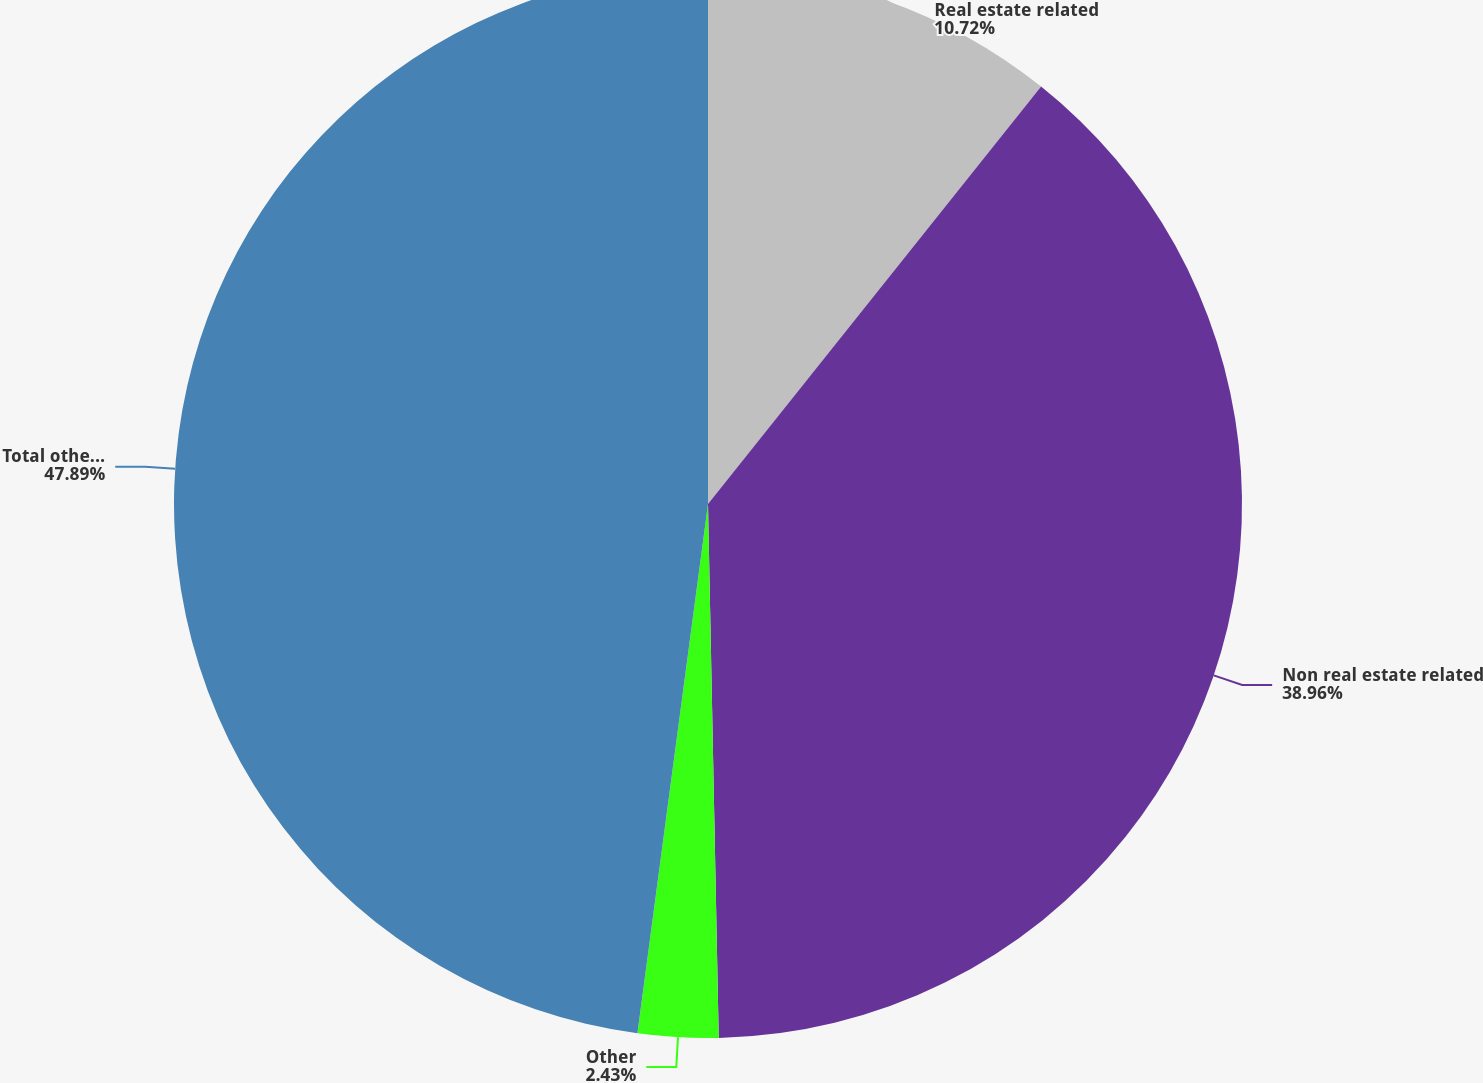Convert chart to OTSL. <chart><loc_0><loc_0><loc_500><loc_500><pie_chart><fcel>Real estate related<fcel>Non real estate related<fcel>Other<fcel>Total other long-term<nl><fcel>10.72%<fcel>38.96%<fcel>2.43%<fcel>47.89%<nl></chart> 